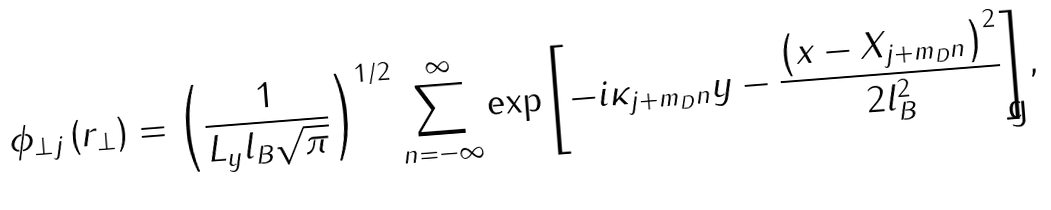Convert formula to latex. <formula><loc_0><loc_0><loc_500><loc_500>\phi _ { \perp j } \left ( { r } _ { \perp } \right ) = \left ( \frac { 1 } { L _ { y } l _ { B } \sqrt { \pi } } \right ) ^ { 1 / 2 } \sum _ { n = - \infty } ^ { \infty } \exp \left [ - i \kappa _ { j + m _ { D } n } y - \frac { \left ( x - X _ { j + m _ { D } n } \right ) ^ { 2 } } { 2 l _ { B } ^ { 2 } } \right ] ,</formula> 